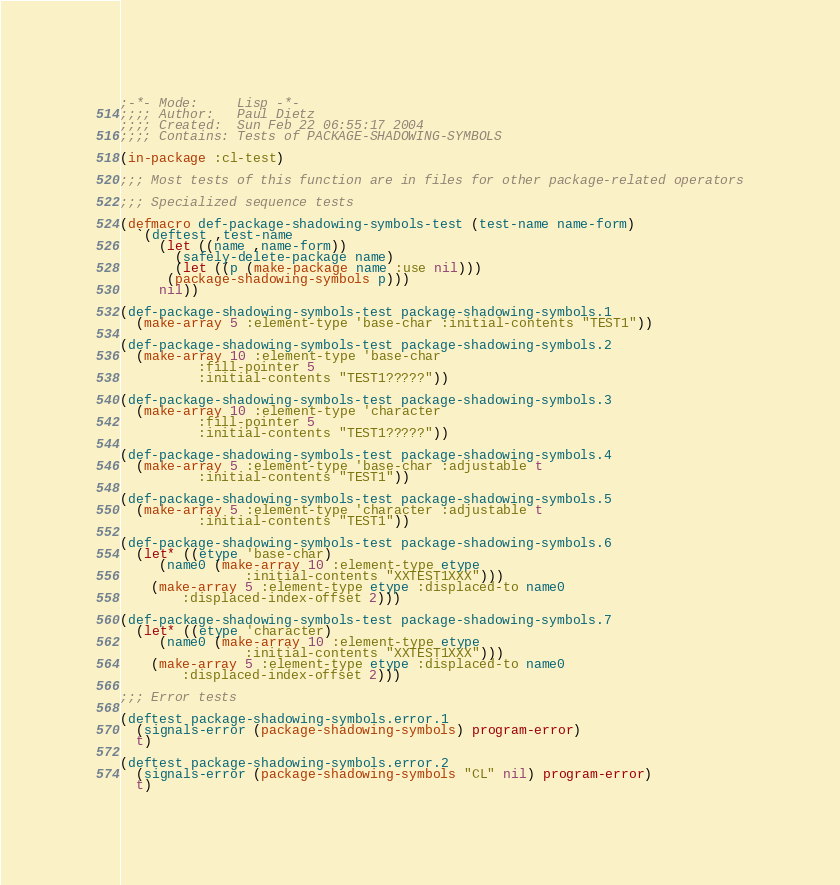Convert code to text. <code><loc_0><loc_0><loc_500><loc_500><_Lisp_>;-*- Mode:     Lisp -*-
;;;; Author:   Paul Dietz
;;;; Created:  Sun Feb 22 06:55:17 2004
;;;; Contains: Tests of PACKAGE-SHADOWING-SYMBOLS

(in-package :cl-test)

;;; Most tests of this function are in files for other package-related operators

;;; Specialized sequence tests

(defmacro def-package-shadowing-symbols-test (test-name name-form)
  `(deftest ,test-name
     (let ((name ,name-form))
       (safely-delete-package name)
       (let ((p (make-package name :use nil)))
	  (package-shadowing-symbols p)))
     nil))

(def-package-shadowing-symbols-test package-shadowing-symbols.1
  (make-array 5 :element-type 'base-char :initial-contents "TEST1"))

(def-package-shadowing-symbols-test package-shadowing-symbols.2
  (make-array 10 :element-type 'base-char
	      :fill-pointer 5
	      :initial-contents "TEST1?????"))

(def-package-shadowing-symbols-test package-shadowing-symbols.3
  (make-array 10 :element-type 'character
	      :fill-pointer 5
	      :initial-contents "TEST1?????"))

(def-package-shadowing-symbols-test package-shadowing-symbols.4
  (make-array 5 :element-type 'base-char :adjustable t
	      :initial-contents "TEST1"))

(def-package-shadowing-symbols-test package-shadowing-symbols.5
  (make-array 5 :element-type 'character :adjustable t
	      :initial-contents "TEST1"))

(def-package-shadowing-symbols-test package-shadowing-symbols.6
  (let* ((etype 'base-char)
	 (name0 (make-array 10 :element-type etype
			    :initial-contents "XXTEST1XXX")))
    (make-array 5 :element-type etype :displaced-to name0
		:displaced-index-offset 2)))

(def-package-shadowing-symbols-test package-shadowing-symbols.7
  (let* ((etype 'character)
	 (name0 (make-array 10 :element-type etype
			    :initial-contents "XXTEST1XXX")))
    (make-array 5 :element-type etype :displaced-to name0
		:displaced-index-offset 2)))

;;; Error tests

(deftest package-shadowing-symbols.error.1
  (signals-error (package-shadowing-symbols) program-error)
  t)

(deftest package-shadowing-symbols.error.2
  (signals-error (package-shadowing-symbols "CL" nil) program-error)
  t)

</code> 